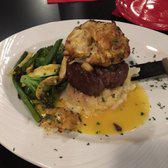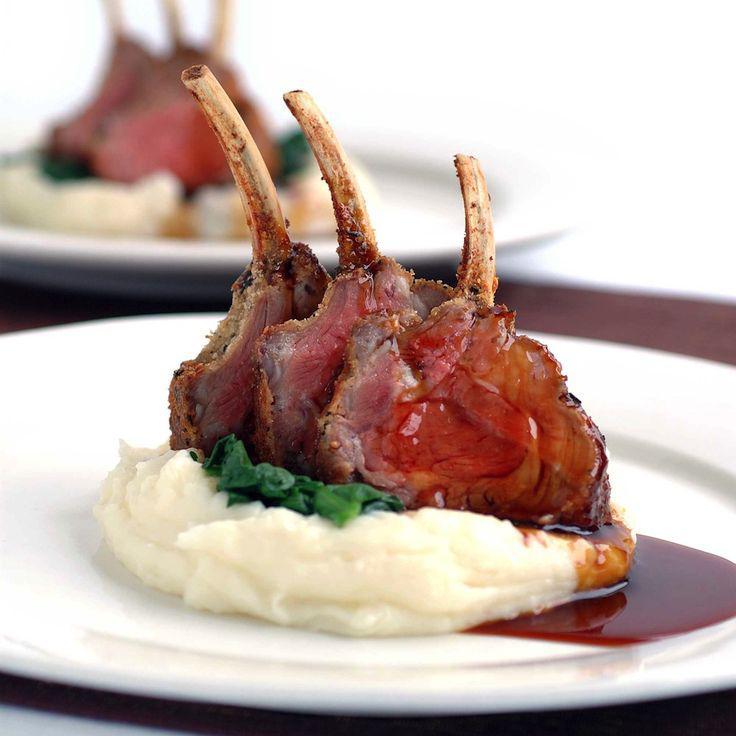The first image is the image on the left, the second image is the image on the right. Analyze the images presented: Is the assertion "In one of the images, a spoon is stuck into the top of the food." valid? Answer yes or no. No. The first image is the image on the left, the second image is the image on the right. Examine the images to the left and right. Is the description "One image shows a white utensil sticking out of a pool of brown gravy in a pile of mashed green food on mashed white food in a pastry crust." accurate? Answer yes or no. No. 